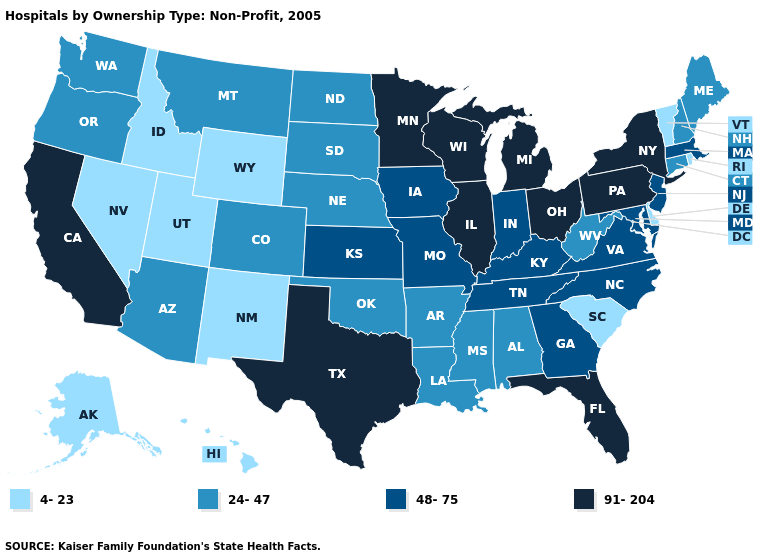What is the value of Ohio?
Be succinct. 91-204. Name the states that have a value in the range 4-23?
Short answer required. Alaska, Delaware, Hawaii, Idaho, Nevada, New Mexico, Rhode Island, South Carolina, Utah, Vermont, Wyoming. Does the first symbol in the legend represent the smallest category?
Give a very brief answer. Yes. Name the states that have a value in the range 4-23?
Give a very brief answer. Alaska, Delaware, Hawaii, Idaho, Nevada, New Mexico, Rhode Island, South Carolina, Utah, Vermont, Wyoming. Name the states that have a value in the range 24-47?
Write a very short answer. Alabama, Arizona, Arkansas, Colorado, Connecticut, Louisiana, Maine, Mississippi, Montana, Nebraska, New Hampshire, North Dakota, Oklahoma, Oregon, South Dakota, Washington, West Virginia. What is the value of Hawaii?
Keep it brief. 4-23. Name the states that have a value in the range 48-75?
Short answer required. Georgia, Indiana, Iowa, Kansas, Kentucky, Maryland, Massachusetts, Missouri, New Jersey, North Carolina, Tennessee, Virginia. Does Arkansas have a higher value than Idaho?
Be succinct. Yes. What is the value of Nevada?
Concise answer only. 4-23. How many symbols are there in the legend?
Concise answer only. 4. What is the value of New York?
Keep it brief. 91-204. How many symbols are there in the legend?
Quick response, please. 4. Name the states that have a value in the range 4-23?
Keep it brief. Alaska, Delaware, Hawaii, Idaho, Nevada, New Mexico, Rhode Island, South Carolina, Utah, Vermont, Wyoming. Does North Carolina have a lower value than Kentucky?
Short answer required. No. What is the highest value in the MidWest ?
Be succinct. 91-204. 